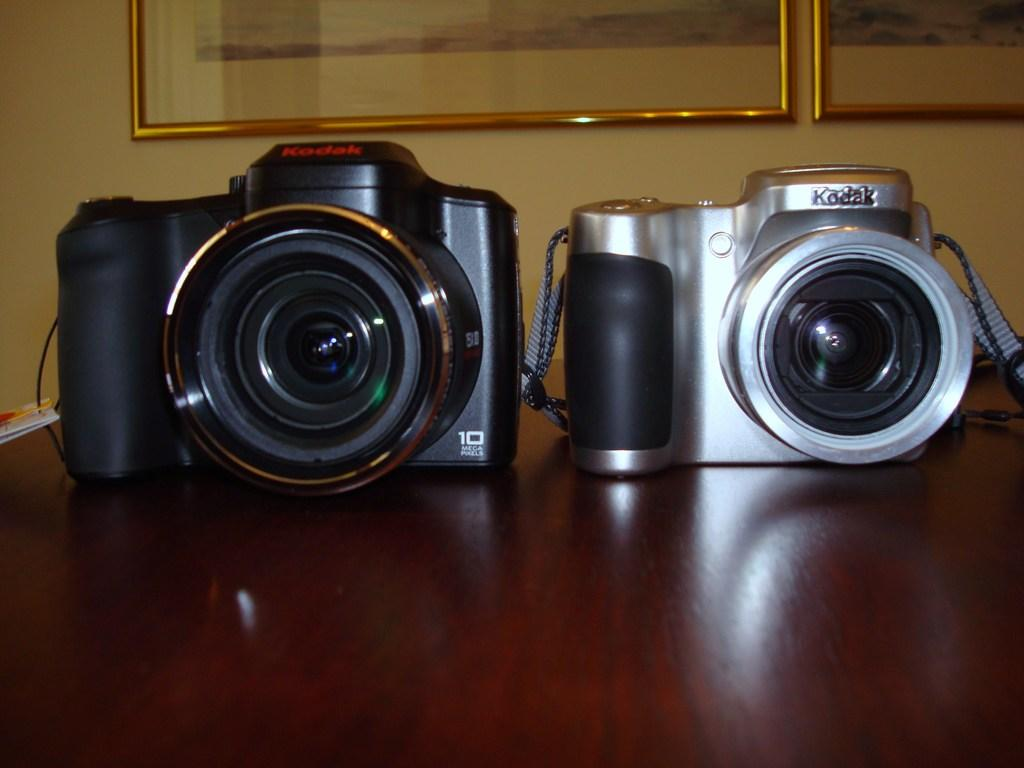How many cameras are visible in the image? There are two cameras in the image. What can be observed about the appearance of the cameras? The cameras are of different colors. What is the surface on which the cameras are placed? The cameras are placed on a wooden surface. What other objects can be seen in the image? There are frames on the wall in the image. Can you tell me how many horses are present in the image? There are no horses present in the image; it features two cameras placed on a wooden surface and frames on the wall. What type of science is being conducted in the image? There is no indication of any scientific activity in the image; it primarily focuses on the cameras and their placement. 